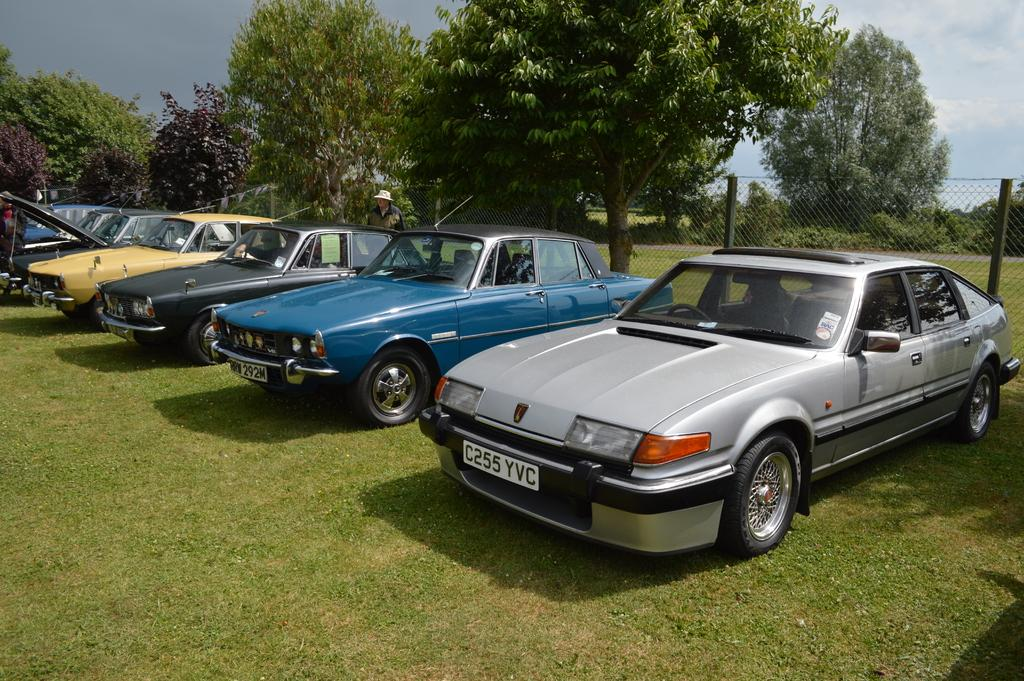What type of vehicles can be seen in the image? There are cars in the image. What is located behind the cars? There is a metal fence behind the cars. What type of vegetation is present at the bottom of the image? Grass is present at the bottom of the image. What can be seen in the background of the image? There are trees and the sky visible in the background of the image. How many icicles are hanging from the cars in the image? There are no icicles present in the image; it is not snowing or cold enough for icicles to form. 